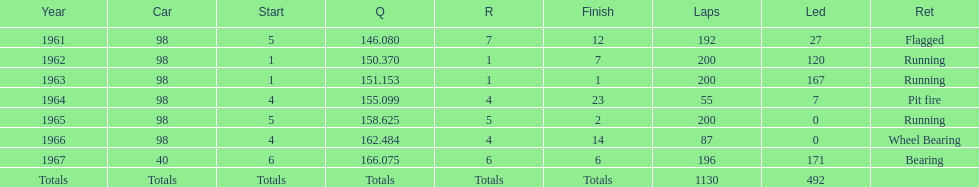Number of times to finish the races running. 3. 